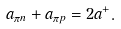Convert formula to latex. <formula><loc_0><loc_0><loc_500><loc_500>a _ { \pi n } + a _ { \pi p } = 2 a ^ { + } .</formula> 